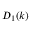<formula> <loc_0><loc_0><loc_500><loc_500>D _ { 1 } ( k )</formula> 